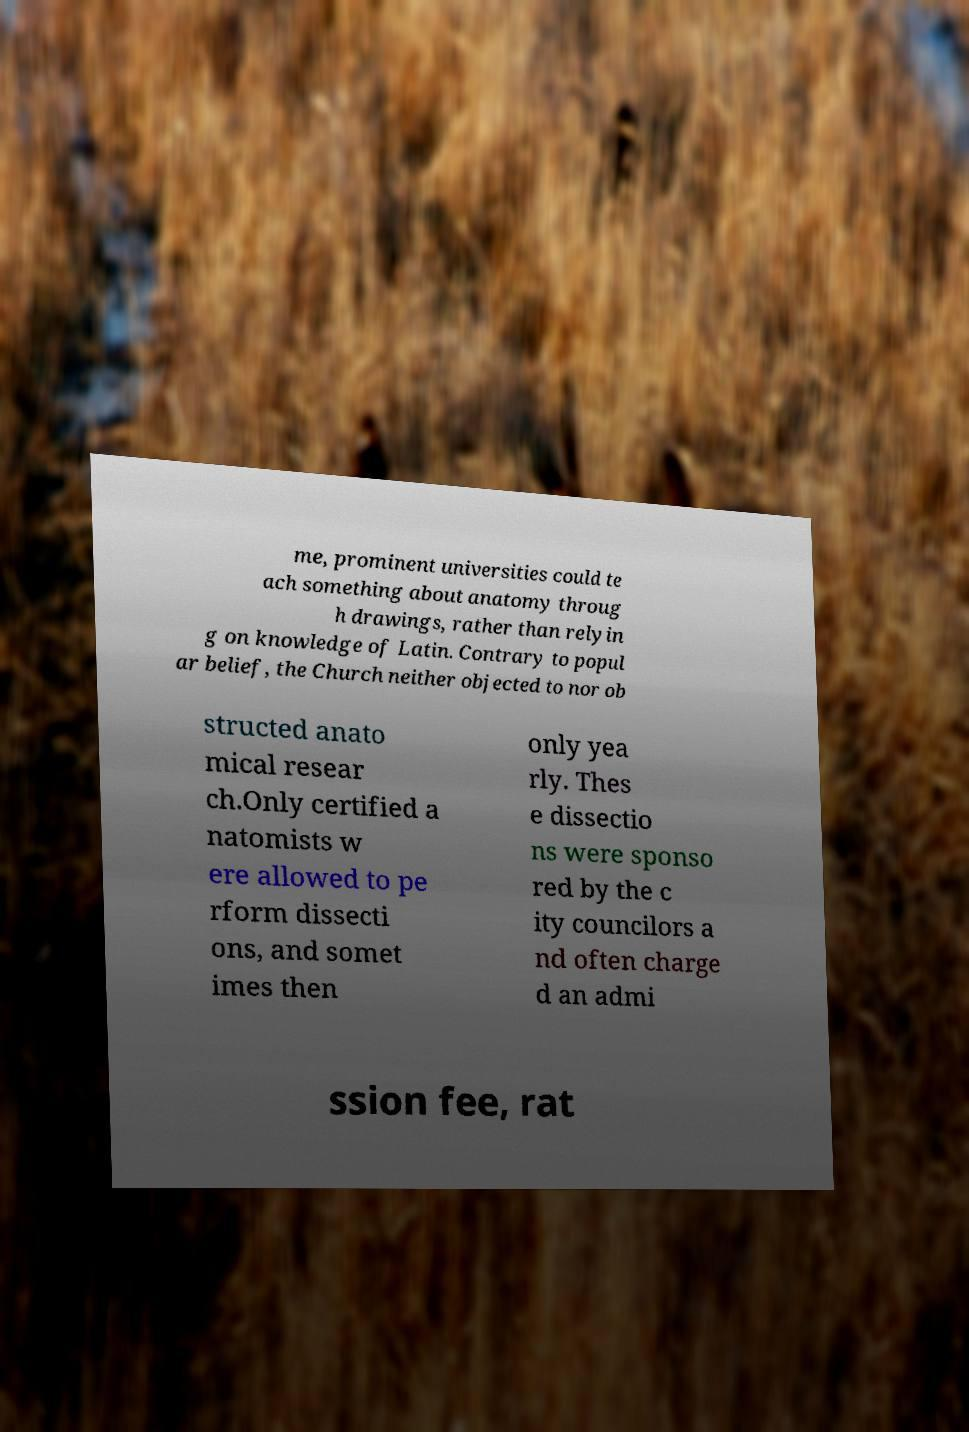Can you read and provide the text displayed in the image?This photo seems to have some interesting text. Can you extract and type it out for me? me, prominent universities could te ach something about anatomy throug h drawings, rather than relyin g on knowledge of Latin. Contrary to popul ar belief, the Church neither objected to nor ob structed anato mical resear ch.Only certified a natomists w ere allowed to pe rform dissecti ons, and somet imes then only yea rly. Thes e dissectio ns were sponso red by the c ity councilors a nd often charge d an admi ssion fee, rat 